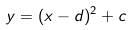<formula> <loc_0><loc_0><loc_500><loc_500>y = ( x - d ) ^ { 2 } + c</formula> 